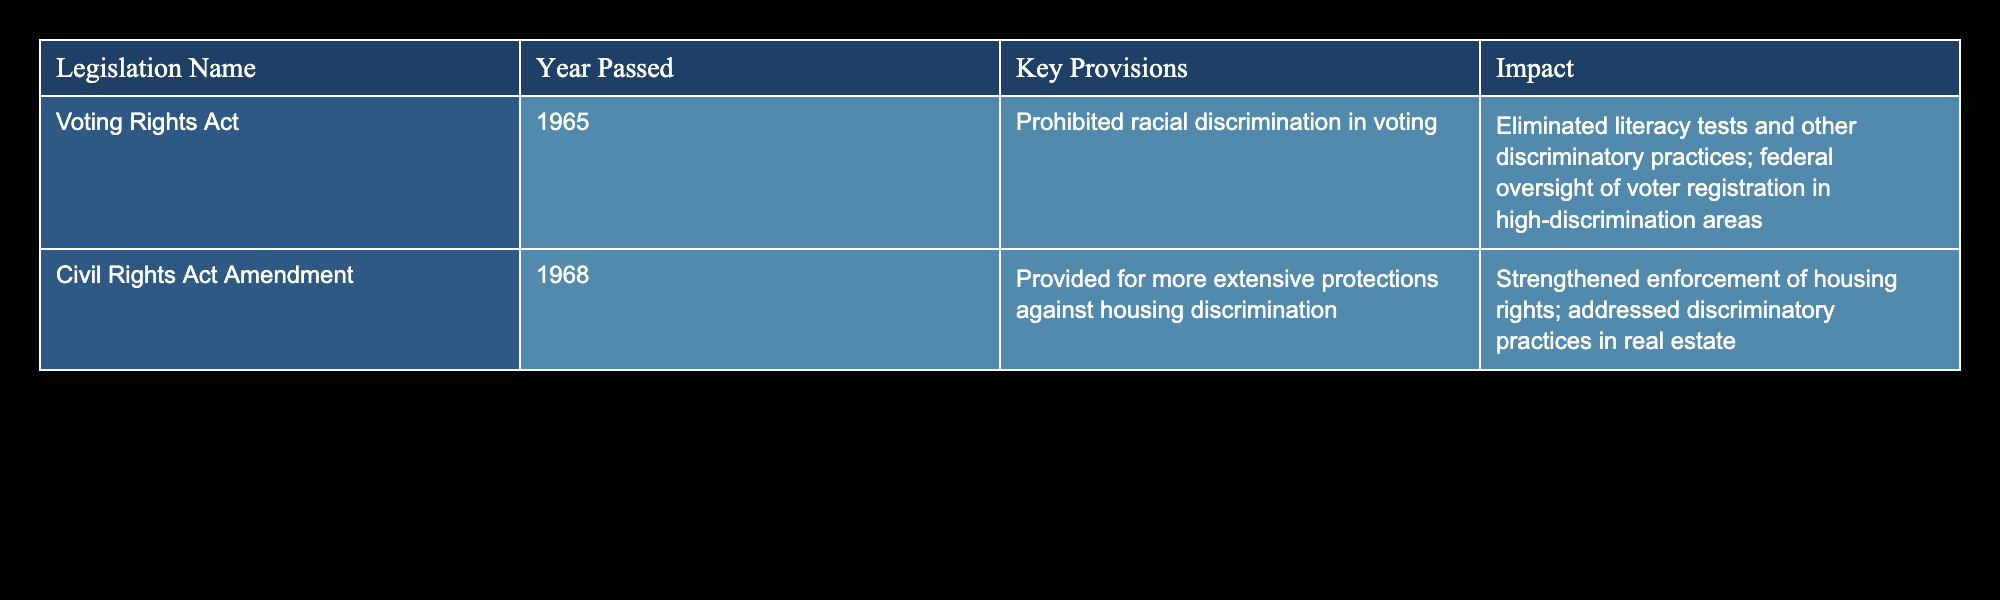What year was the Voting Rights Act passed? The table lists the "Voting Rights Act" under the column "Year Passed," which shows 1965. This is a direct retrieval from the table.
Answer: 1965 What are the key provisions of the Civil Rights Act Amendment of 1968? By looking at the row for "Civil Rights Act Amendment," the table specifies that the key provisions include providing more extensive protections against housing discrimination. This is also a direct retrieval from the table.
Answer: Provided for more extensive protections against housing discrimination Did the Voting Rights Act eliminate literacy tests? The table indicates that one of the key provisions of the Voting Rights Act is to prohibit racial discrimination in voting, which includes eliminating literacy tests as a discriminatory practice. Therefore, the answer is yes.
Answer: Yes How many pieces of major civil rights legislation are listed in the table? The table shows two rows of data, each representing a piece of major civil rights legislation. By counting these rows, we can see that there are 2 pieces of legislation in total.
Answer: 2 What was the impact of the Civil Rights Act Amendment of 1968? From the table, the impact of this legislation is described as strengthening enforcement of housing rights and addressing discriminatory practices in real estate, which can be directly referenced.
Answer: Strengthened enforcement of housing rights; addressed discriminatory practices in real estate Is the year 1965 associated with housing discrimination legislation? The year 1965 is associated with the Voting Rights Act, which focuses on voting discrimination rather than housing discrimination. The Civil Rights Act Amendment of 1968 is more closely related to housing discrimination. Hence, the answer is no.
Answer: No What difference in impact is noted between the Voting Rights Act and the Civil Rights Act Amendment? The Voting Rights Act primarily addresses the elimination of discriminatory voting practices, while the Civil Rights Act Amendment specifically strengthens housing rights and addresses real estate discrimination. This requires comparing the impacts of both pieces of legislation outlined in the table.
Answer: The Voting Rights Act focuses on voting discrimination; the Civil Rights Act Amendment focuses on housing discrimination What would be the effect on voter registration in areas with a history of discrimination due to the Voting Rights Act? The table indicates that the Voting Rights Act includes federal oversight of voter registration in high-discrimination areas, which implies a direct positive effect on ensuring fair voter registration practices in these areas. Thus, the answer is they would be positively affected by increased oversight.
Answer: They would be positively affected by increased oversight 